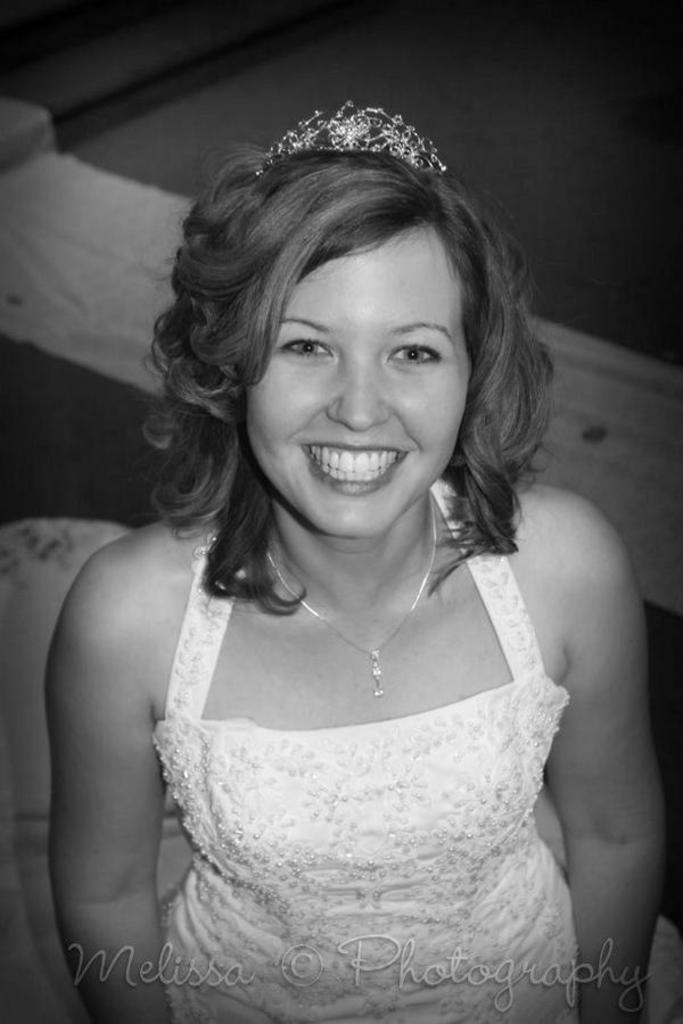What is the color scheme of the image? The image is black and white. Who is present in the image? There is a woman in the image. What is the woman's expression? The woman is smiling. Can you describe the objects behind the woman? There are objects behind the woman, but their specific details are not clear due to the black and white color scheme. Is there any additional information or branding on the image? Yes, there is a watermark on the image. How many dogs are present in the image? There are no dogs present in the image; it features a woman with a black and white color scheme and a watermark. What type of belief system does the woman in the image follow? There is no information about the woman's belief system in the image. 